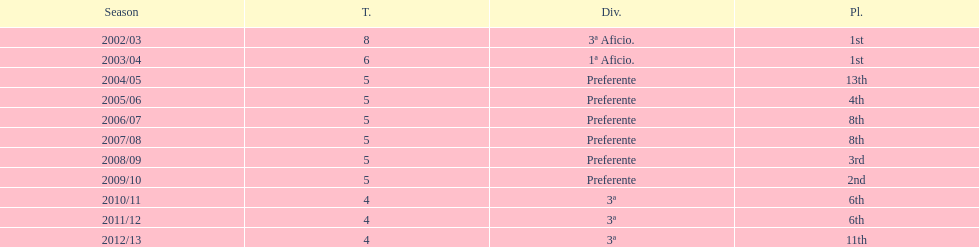What place was 1a aficio and 3a aficio? 1st. 